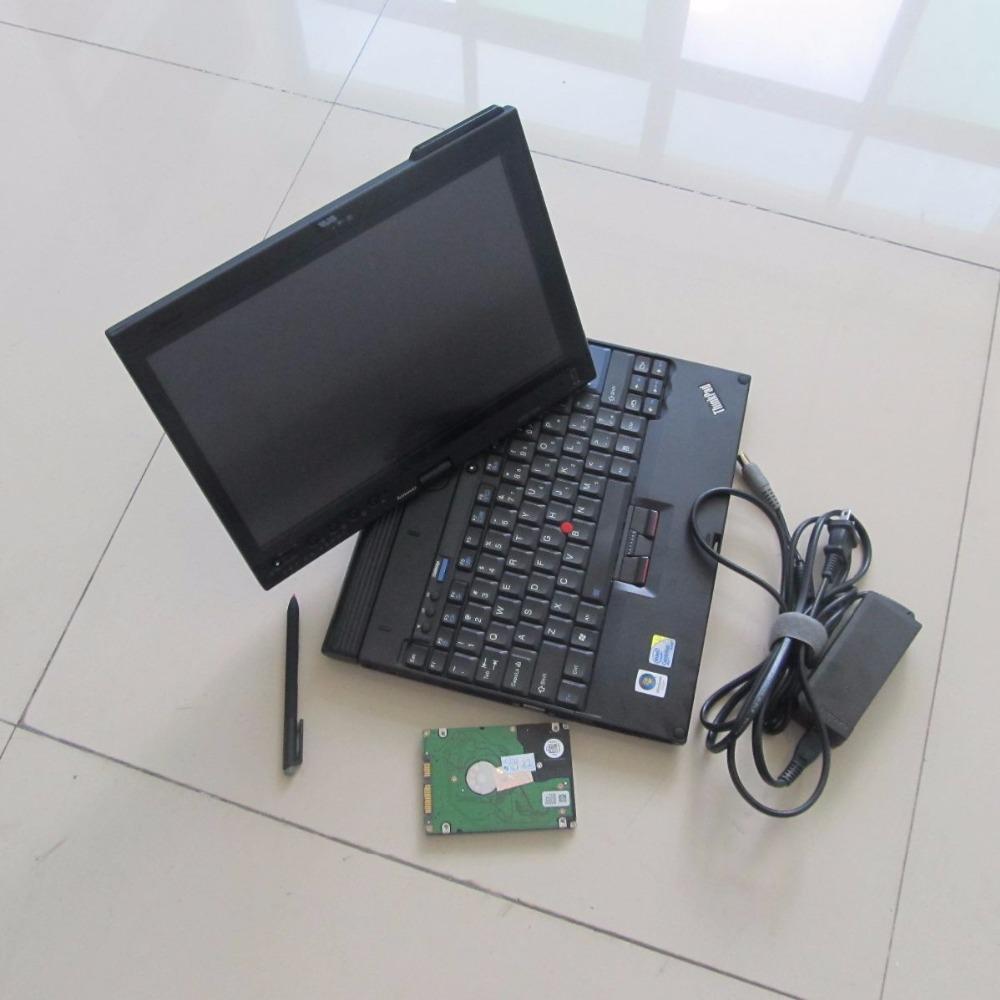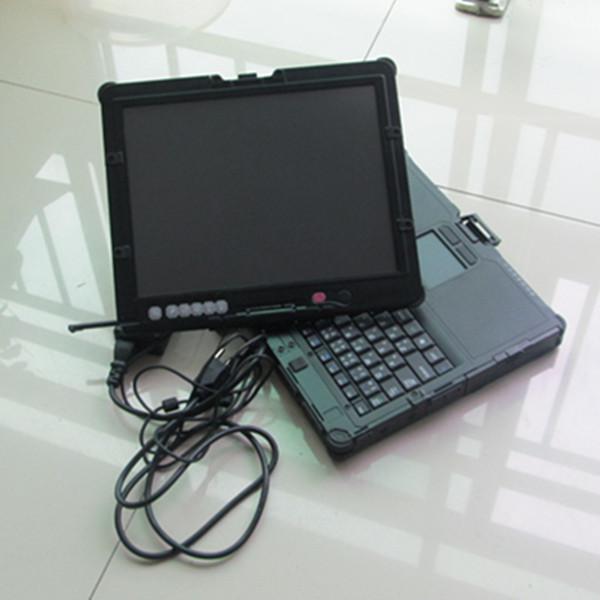The first image is the image on the left, the second image is the image on the right. Analyze the images presented: Is the assertion "There are three computers" valid? Answer yes or no. No. The first image is the image on the left, the second image is the image on the right. For the images displayed, is the sentence "There are two laptops in one of the images." factually correct? Answer yes or no. No. 